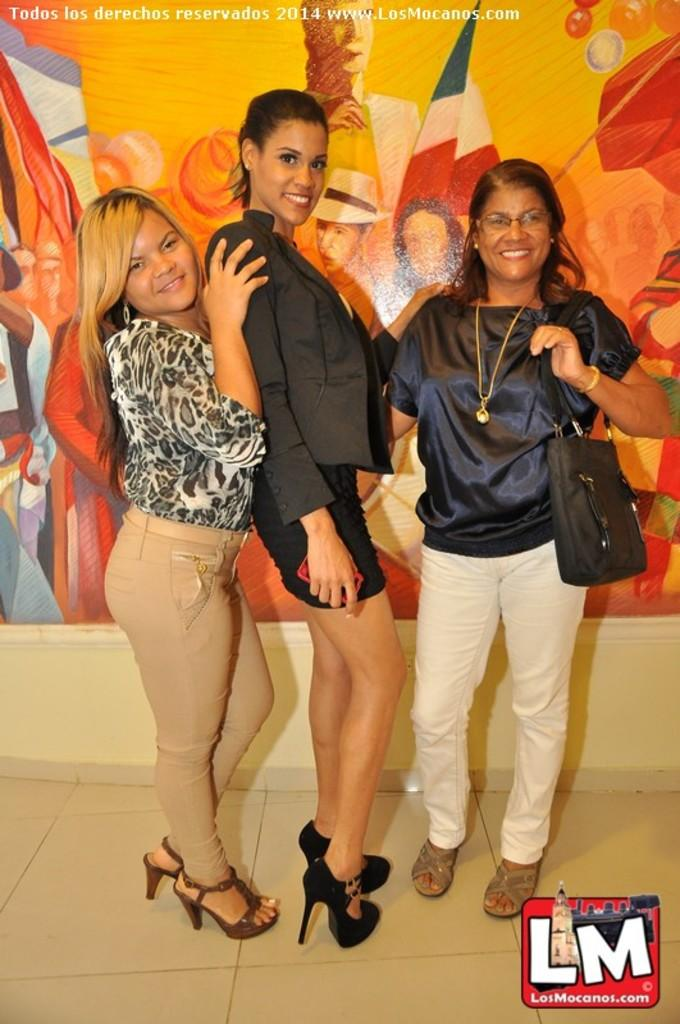How many women are in the image? There are three women in the image. What are the women doing in the image? The women are standing on the floor. Can you describe the woman on the right side of the image? The woman on the right side is wearing a handbag and smiling. What can be seen in the background of the image? There is a poster on the wall in the background of the image. What type of horn is visible on the woman's face in the image? There is no horn visible on any of the women's faces in the image. 